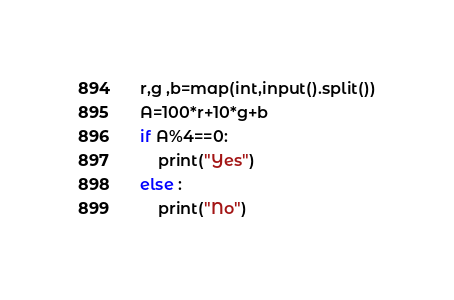Convert code to text. <code><loc_0><loc_0><loc_500><loc_500><_Python_>r,g ,b=map(int,input().split())
A=100*r+10*g+b
if A%4==0:
    print("Yes")
else :
    print("No")</code> 